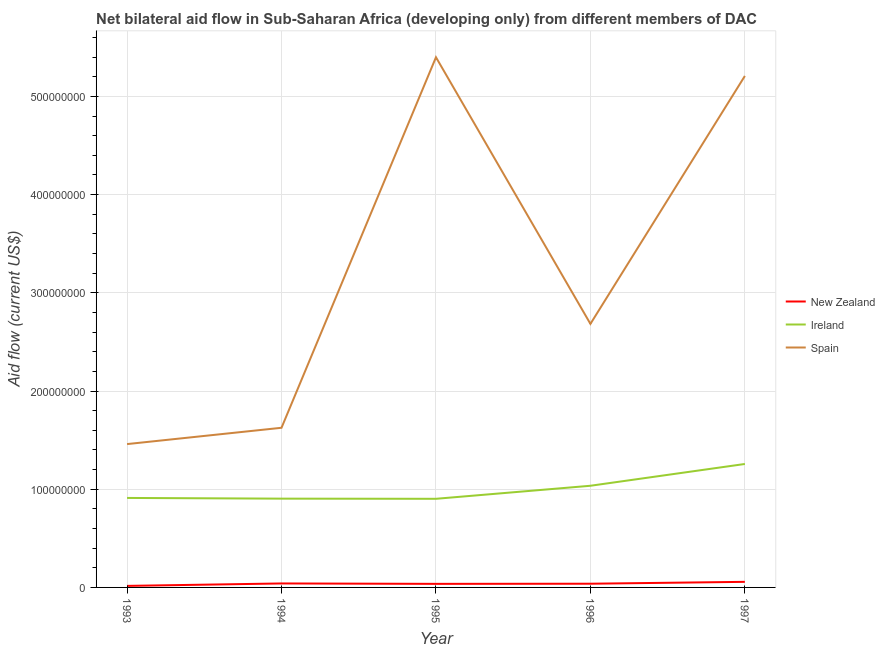Does the line corresponding to amount of aid provided by ireland intersect with the line corresponding to amount of aid provided by spain?
Provide a succinct answer. No. Is the number of lines equal to the number of legend labels?
Keep it short and to the point. Yes. What is the amount of aid provided by ireland in 1995?
Your answer should be compact. 9.03e+07. Across all years, what is the maximum amount of aid provided by spain?
Your answer should be very brief. 5.40e+08. Across all years, what is the minimum amount of aid provided by ireland?
Your response must be concise. 9.03e+07. What is the total amount of aid provided by new zealand in the graph?
Ensure brevity in your answer.  1.87e+07. What is the difference between the amount of aid provided by ireland in 1995 and that in 1996?
Ensure brevity in your answer.  -1.33e+07. What is the difference between the amount of aid provided by spain in 1997 and the amount of aid provided by ireland in 1996?
Your response must be concise. 4.17e+08. What is the average amount of aid provided by new zealand per year?
Make the answer very short. 3.74e+06. In the year 1995, what is the difference between the amount of aid provided by ireland and amount of aid provided by spain?
Your answer should be compact. -4.50e+08. What is the ratio of the amount of aid provided by ireland in 1994 to that in 1995?
Ensure brevity in your answer.  1. Is the amount of aid provided by ireland in 1996 less than that in 1997?
Keep it short and to the point. Yes. Is the difference between the amount of aid provided by new zealand in 1994 and 1996 greater than the difference between the amount of aid provided by spain in 1994 and 1996?
Offer a very short reply. Yes. What is the difference between the highest and the second highest amount of aid provided by new zealand?
Provide a succinct answer. 1.63e+06. What is the difference between the highest and the lowest amount of aid provided by ireland?
Offer a very short reply. 3.55e+07. Is the sum of the amount of aid provided by new zealand in 1995 and 1997 greater than the maximum amount of aid provided by ireland across all years?
Provide a succinct answer. No. Is it the case that in every year, the sum of the amount of aid provided by new zealand and amount of aid provided by ireland is greater than the amount of aid provided by spain?
Your answer should be very brief. No. Does the amount of aid provided by ireland monotonically increase over the years?
Make the answer very short. No. Is the amount of aid provided by new zealand strictly greater than the amount of aid provided by spain over the years?
Make the answer very short. No. How many lines are there?
Your response must be concise. 3. What is the difference between two consecutive major ticks on the Y-axis?
Provide a succinct answer. 1.00e+08. Does the graph contain grids?
Your answer should be very brief. Yes. Where does the legend appear in the graph?
Ensure brevity in your answer.  Center right. How many legend labels are there?
Offer a terse response. 3. What is the title of the graph?
Your answer should be compact. Net bilateral aid flow in Sub-Saharan Africa (developing only) from different members of DAC. What is the label or title of the X-axis?
Your answer should be compact. Year. What is the label or title of the Y-axis?
Your response must be concise. Aid flow (current US$). What is the Aid flow (current US$) in New Zealand in 1993?
Make the answer very short. 1.57e+06. What is the Aid flow (current US$) of Ireland in 1993?
Keep it short and to the point. 9.11e+07. What is the Aid flow (current US$) in Spain in 1993?
Your answer should be very brief. 1.46e+08. What is the Aid flow (current US$) in New Zealand in 1994?
Ensure brevity in your answer.  4.05e+06. What is the Aid flow (current US$) of Ireland in 1994?
Provide a short and direct response. 9.04e+07. What is the Aid flow (current US$) in Spain in 1994?
Your response must be concise. 1.63e+08. What is the Aid flow (current US$) in New Zealand in 1995?
Your answer should be compact. 3.63e+06. What is the Aid flow (current US$) in Ireland in 1995?
Give a very brief answer. 9.03e+07. What is the Aid flow (current US$) of Spain in 1995?
Your answer should be very brief. 5.40e+08. What is the Aid flow (current US$) of New Zealand in 1996?
Give a very brief answer. 3.78e+06. What is the Aid flow (current US$) in Ireland in 1996?
Your answer should be compact. 1.04e+08. What is the Aid flow (current US$) of Spain in 1996?
Your answer should be very brief. 2.68e+08. What is the Aid flow (current US$) in New Zealand in 1997?
Offer a very short reply. 5.68e+06. What is the Aid flow (current US$) of Ireland in 1997?
Offer a terse response. 1.26e+08. What is the Aid flow (current US$) in Spain in 1997?
Provide a short and direct response. 5.21e+08. Across all years, what is the maximum Aid flow (current US$) of New Zealand?
Offer a terse response. 5.68e+06. Across all years, what is the maximum Aid flow (current US$) of Ireland?
Your answer should be very brief. 1.26e+08. Across all years, what is the maximum Aid flow (current US$) of Spain?
Make the answer very short. 5.40e+08. Across all years, what is the minimum Aid flow (current US$) of New Zealand?
Offer a very short reply. 1.57e+06. Across all years, what is the minimum Aid flow (current US$) of Ireland?
Provide a succinct answer. 9.03e+07. Across all years, what is the minimum Aid flow (current US$) of Spain?
Provide a short and direct response. 1.46e+08. What is the total Aid flow (current US$) of New Zealand in the graph?
Your response must be concise. 1.87e+07. What is the total Aid flow (current US$) of Ireland in the graph?
Make the answer very short. 5.01e+08. What is the total Aid flow (current US$) in Spain in the graph?
Offer a very short reply. 1.64e+09. What is the difference between the Aid flow (current US$) in New Zealand in 1993 and that in 1994?
Give a very brief answer. -2.48e+06. What is the difference between the Aid flow (current US$) in Ireland in 1993 and that in 1994?
Keep it short and to the point. 7.20e+05. What is the difference between the Aid flow (current US$) of Spain in 1993 and that in 1994?
Your answer should be compact. -1.66e+07. What is the difference between the Aid flow (current US$) in New Zealand in 1993 and that in 1995?
Your response must be concise. -2.06e+06. What is the difference between the Aid flow (current US$) in Ireland in 1993 and that in 1995?
Provide a short and direct response. 8.70e+05. What is the difference between the Aid flow (current US$) of Spain in 1993 and that in 1995?
Your answer should be very brief. -3.94e+08. What is the difference between the Aid flow (current US$) in New Zealand in 1993 and that in 1996?
Provide a short and direct response. -2.21e+06. What is the difference between the Aid flow (current US$) in Ireland in 1993 and that in 1996?
Your response must be concise. -1.24e+07. What is the difference between the Aid flow (current US$) of Spain in 1993 and that in 1996?
Make the answer very short. -1.22e+08. What is the difference between the Aid flow (current US$) in New Zealand in 1993 and that in 1997?
Your answer should be compact. -4.11e+06. What is the difference between the Aid flow (current US$) of Ireland in 1993 and that in 1997?
Offer a terse response. -3.46e+07. What is the difference between the Aid flow (current US$) in Spain in 1993 and that in 1997?
Offer a terse response. -3.75e+08. What is the difference between the Aid flow (current US$) in Ireland in 1994 and that in 1995?
Ensure brevity in your answer.  1.50e+05. What is the difference between the Aid flow (current US$) in Spain in 1994 and that in 1995?
Offer a terse response. -3.77e+08. What is the difference between the Aid flow (current US$) of Ireland in 1994 and that in 1996?
Your answer should be very brief. -1.31e+07. What is the difference between the Aid flow (current US$) in Spain in 1994 and that in 1996?
Give a very brief answer. -1.06e+08. What is the difference between the Aid flow (current US$) of New Zealand in 1994 and that in 1997?
Your answer should be compact. -1.63e+06. What is the difference between the Aid flow (current US$) in Ireland in 1994 and that in 1997?
Keep it short and to the point. -3.53e+07. What is the difference between the Aid flow (current US$) in Spain in 1994 and that in 1997?
Provide a short and direct response. -3.58e+08. What is the difference between the Aid flow (current US$) in New Zealand in 1995 and that in 1996?
Your answer should be compact. -1.50e+05. What is the difference between the Aid flow (current US$) of Ireland in 1995 and that in 1996?
Keep it short and to the point. -1.33e+07. What is the difference between the Aid flow (current US$) of Spain in 1995 and that in 1996?
Give a very brief answer. 2.72e+08. What is the difference between the Aid flow (current US$) of New Zealand in 1995 and that in 1997?
Provide a short and direct response. -2.05e+06. What is the difference between the Aid flow (current US$) in Ireland in 1995 and that in 1997?
Offer a terse response. -3.55e+07. What is the difference between the Aid flow (current US$) in Spain in 1995 and that in 1997?
Your answer should be very brief. 1.90e+07. What is the difference between the Aid flow (current US$) of New Zealand in 1996 and that in 1997?
Offer a very short reply. -1.90e+06. What is the difference between the Aid flow (current US$) of Ireland in 1996 and that in 1997?
Your answer should be very brief. -2.22e+07. What is the difference between the Aid flow (current US$) in Spain in 1996 and that in 1997?
Ensure brevity in your answer.  -2.52e+08. What is the difference between the Aid flow (current US$) in New Zealand in 1993 and the Aid flow (current US$) in Ireland in 1994?
Keep it short and to the point. -8.88e+07. What is the difference between the Aid flow (current US$) in New Zealand in 1993 and the Aid flow (current US$) in Spain in 1994?
Your answer should be compact. -1.61e+08. What is the difference between the Aid flow (current US$) of Ireland in 1993 and the Aid flow (current US$) of Spain in 1994?
Provide a succinct answer. -7.14e+07. What is the difference between the Aid flow (current US$) of New Zealand in 1993 and the Aid flow (current US$) of Ireland in 1995?
Offer a terse response. -8.87e+07. What is the difference between the Aid flow (current US$) of New Zealand in 1993 and the Aid flow (current US$) of Spain in 1995?
Your response must be concise. -5.38e+08. What is the difference between the Aid flow (current US$) of Ireland in 1993 and the Aid flow (current US$) of Spain in 1995?
Your answer should be very brief. -4.49e+08. What is the difference between the Aid flow (current US$) of New Zealand in 1993 and the Aid flow (current US$) of Ireland in 1996?
Give a very brief answer. -1.02e+08. What is the difference between the Aid flow (current US$) of New Zealand in 1993 and the Aid flow (current US$) of Spain in 1996?
Ensure brevity in your answer.  -2.67e+08. What is the difference between the Aid flow (current US$) in Ireland in 1993 and the Aid flow (current US$) in Spain in 1996?
Your answer should be compact. -1.77e+08. What is the difference between the Aid flow (current US$) of New Zealand in 1993 and the Aid flow (current US$) of Ireland in 1997?
Your response must be concise. -1.24e+08. What is the difference between the Aid flow (current US$) in New Zealand in 1993 and the Aid flow (current US$) in Spain in 1997?
Give a very brief answer. -5.19e+08. What is the difference between the Aid flow (current US$) of Ireland in 1993 and the Aid flow (current US$) of Spain in 1997?
Your answer should be very brief. -4.30e+08. What is the difference between the Aid flow (current US$) of New Zealand in 1994 and the Aid flow (current US$) of Ireland in 1995?
Make the answer very short. -8.62e+07. What is the difference between the Aid flow (current US$) of New Zealand in 1994 and the Aid flow (current US$) of Spain in 1995?
Ensure brevity in your answer.  -5.36e+08. What is the difference between the Aid flow (current US$) of Ireland in 1994 and the Aid flow (current US$) of Spain in 1995?
Give a very brief answer. -4.49e+08. What is the difference between the Aid flow (current US$) of New Zealand in 1994 and the Aid flow (current US$) of Ireland in 1996?
Offer a very short reply. -9.95e+07. What is the difference between the Aid flow (current US$) of New Zealand in 1994 and the Aid flow (current US$) of Spain in 1996?
Your answer should be very brief. -2.64e+08. What is the difference between the Aid flow (current US$) of Ireland in 1994 and the Aid flow (current US$) of Spain in 1996?
Offer a very short reply. -1.78e+08. What is the difference between the Aid flow (current US$) in New Zealand in 1994 and the Aid flow (current US$) in Ireland in 1997?
Your answer should be very brief. -1.22e+08. What is the difference between the Aid flow (current US$) of New Zealand in 1994 and the Aid flow (current US$) of Spain in 1997?
Offer a terse response. -5.17e+08. What is the difference between the Aid flow (current US$) of Ireland in 1994 and the Aid flow (current US$) of Spain in 1997?
Keep it short and to the point. -4.30e+08. What is the difference between the Aid flow (current US$) of New Zealand in 1995 and the Aid flow (current US$) of Ireland in 1996?
Keep it short and to the point. -9.99e+07. What is the difference between the Aid flow (current US$) in New Zealand in 1995 and the Aid flow (current US$) in Spain in 1996?
Offer a terse response. -2.65e+08. What is the difference between the Aid flow (current US$) of Ireland in 1995 and the Aid flow (current US$) of Spain in 1996?
Offer a terse response. -1.78e+08. What is the difference between the Aid flow (current US$) of New Zealand in 1995 and the Aid flow (current US$) of Ireland in 1997?
Your answer should be compact. -1.22e+08. What is the difference between the Aid flow (current US$) of New Zealand in 1995 and the Aid flow (current US$) of Spain in 1997?
Keep it short and to the point. -5.17e+08. What is the difference between the Aid flow (current US$) in Ireland in 1995 and the Aid flow (current US$) in Spain in 1997?
Offer a terse response. -4.31e+08. What is the difference between the Aid flow (current US$) of New Zealand in 1996 and the Aid flow (current US$) of Ireland in 1997?
Your answer should be very brief. -1.22e+08. What is the difference between the Aid flow (current US$) in New Zealand in 1996 and the Aid flow (current US$) in Spain in 1997?
Make the answer very short. -5.17e+08. What is the difference between the Aid flow (current US$) of Ireland in 1996 and the Aid flow (current US$) of Spain in 1997?
Your response must be concise. -4.17e+08. What is the average Aid flow (current US$) of New Zealand per year?
Your answer should be compact. 3.74e+06. What is the average Aid flow (current US$) in Ireland per year?
Give a very brief answer. 1.00e+08. What is the average Aid flow (current US$) of Spain per year?
Give a very brief answer. 3.28e+08. In the year 1993, what is the difference between the Aid flow (current US$) in New Zealand and Aid flow (current US$) in Ireland?
Offer a terse response. -8.96e+07. In the year 1993, what is the difference between the Aid flow (current US$) in New Zealand and Aid flow (current US$) in Spain?
Offer a terse response. -1.44e+08. In the year 1993, what is the difference between the Aid flow (current US$) in Ireland and Aid flow (current US$) in Spain?
Ensure brevity in your answer.  -5.48e+07. In the year 1994, what is the difference between the Aid flow (current US$) of New Zealand and Aid flow (current US$) of Ireland?
Offer a terse response. -8.64e+07. In the year 1994, what is the difference between the Aid flow (current US$) in New Zealand and Aid flow (current US$) in Spain?
Your answer should be compact. -1.59e+08. In the year 1994, what is the difference between the Aid flow (current US$) of Ireland and Aid flow (current US$) of Spain?
Keep it short and to the point. -7.22e+07. In the year 1995, what is the difference between the Aid flow (current US$) in New Zealand and Aid flow (current US$) in Ireland?
Keep it short and to the point. -8.66e+07. In the year 1995, what is the difference between the Aid flow (current US$) in New Zealand and Aid flow (current US$) in Spain?
Offer a very short reply. -5.36e+08. In the year 1995, what is the difference between the Aid flow (current US$) in Ireland and Aid flow (current US$) in Spain?
Give a very brief answer. -4.50e+08. In the year 1996, what is the difference between the Aid flow (current US$) in New Zealand and Aid flow (current US$) in Ireland?
Your answer should be very brief. -9.98e+07. In the year 1996, what is the difference between the Aid flow (current US$) in New Zealand and Aid flow (current US$) in Spain?
Keep it short and to the point. -2.65e+08. In the year 1996, what is the difference between the Aid flow (current US$) in Ireland and Aid flow (current US$) in Spain?
Offer a very short reply. -1.65e+08. In the year 1997, what is the difference between the Aid flow (current US$) of New Zealand and Aid flow (current US$) of Ireland?
Provide a short and direct response. -1.20e+08. In the year 1997, what is the difference between the Aid flow (current US$) of New Zealand and Aid flow (current US$) of Spain?
Give a very brief answer. -5.15e+08. In the year 1997, what is the difference between the Aid flow (current US$) in Ireland and Aid flow (current US$) in Spain?
Make the answer very short. -3.95e+08. What is the ratio of the Aid flow (current US$) of New Zealand in 1993 to that in 1994?
Ensure brevity in your answer.  0.39. What is the ratio of the Aid flow (current US$) in Spain in 1993 to that in 1994?
Your response must be concise. 0.9. What is the ratio of the Aid flow (current US$) in New Zealand in 1993 to that in 1995?
Ensure brevity in your answer.  0.43. What is the ratio of the Aid flow (current US$) in Ireland in 1993 to that in 1995?
Provide a succinct answer. 1.01. What is the ratio of the Aid flow (current US$) of Spain in 1993 to that in 1995?
Offer a very short reply. 0.27. What is the ratio of the Aid flow (current US$) of New Zealand in 1993 to that in 1996?
Your answer should be very brief. 0.42. What is the ratio of the Aid flow (current US$) in Ireland in 1993 to that in 1996?
Offer a terse response. 0.88. What is the ratio of the Aid flow (current US$) of Spain in 1993 to that in 1996?
Your answer should be compact. 0.54. What is the ratio of the Aid flow (current US$) in New Zealand in 1993 to that in 1997?
Keep it short and to the point. 0.28. What is the ratio of the Aid flow (current US$) in Ireland in 1993 to that in 1997?
Offer a very short reply. 0.72. What is the ratio of the Aid flow (current US$) of Spain in 1993 to that in 1997?
Offer a very short reply. 0.28. What is the ratio of the Aid flow (current US$) of New Zealand in 1994 to that in 1995?
Make the answer very short. 1.12. What is the ratio of the Aid flow (current US$) in Ireland in 1994 to that in 1995?
Offer a very short reply. 1. What is the ratio of the Aid flow (current US$) of Spain in 1994 to that in 1995?
Provide a succinct answer. 0.3. What is the ratio of the Aid flow (current US$) in New Zealand in 1994 to that in 1996?
Provide a short and direct response. 1.07. What is the ratio of the Aid flow (current US$) in Ireland in 1994 to that in 1996?
Make the answer very short. 0.87. What is the ratio of the Aid flow (current US$) of Spain in 1994 to that in 1996?
Provide a succinct answer. 0.61. What is the ratio of the Aid flow (current US$) of New Zealand in 1994 to that in 1997?
Provide a short and direct response. 0.71. What is the ratio of the Aid flow (current US$) of Ireland in 1994 to that in 1997?
Make the answer very short. 0.72. What is the ratio of the Aid flow (current US$) of Spain in 1994 to that in 1997?
Offer a terse response. 0.31. What is the ratio of the Aid flow (current US$) of New Zealand in 1995 to that in 1996?
Provide a succinct answer. 0.96. What is the ratio of the Aid flow (current US$) in Ireland in 1995 to that in 1996?
Your response must be concise. 0.87. What is the ratio of the Aid flow (current US$) of Spain in 1995 to that in 1996?
Ensure brevity in your answer.  2.01. What is the ratio of the Aid flow (current US$) of New Zealand in 1995 to that in 1997?
Your answer should be very brief. 0.64. What is the ratio of the Aid flow (current US$) of Ireland in 1995 to that in 1997?
Give a very brief answer. 0.72. What is the ratio of the Aid flow (current US$) of Spain in 1995 to that in 1997?
Provide a short and direct response. 1.04. What is the ratio of the Aid flow (current US$) in New Zealand in 1996 to that in 1997?
Offer a very short reply. 0.67. What is the ratio of the Aid flow (current US$) of Ireland in 1996 to that in 1997?
Provide a short and direct response. 0.82. What is the ratio of the Aid flow (current US$) in Spain in 1996 to that in 1997?
Offer a terse response. 0.52. What is the difference between the highest and the second highest Aid flow (current US$) of New Zealand?
Your answer should be compact. 1.63e+06. What is the difference between the highest and the second highest Aid flow (current US$) of Ireland?
Ensure brevity in your answer.  2.22e+07. What is the difference between the highest and the second highest Aid flow (current US$) of Spain?
Give a very brief answer. 1.90e+07. What is the difference between the highest and the lowest Aid flow (current US$) in New Zealand?
Give a very brief answer. 4.11e+06. What is the difference between the highest and the lowest Aid flow (current US$) of Ireland?
Make the answer very short. 3.55e+07. What is the difference between the highest and the lowest Aid flow (current US$) in Spain?
Make the answer very short. 3.94e+08. 